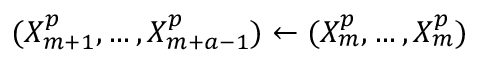Convert formula to latex. <formula><loc_0><loc_0><loc_500><loc_500>( X _ { m + 1 } ^ { p } , \hdots , X _ { m + a - 1 } ^ { p } ) \gets ( X _ { m } ^ { p } , \hdots , X _ { m } ^ { p } )</formula> 